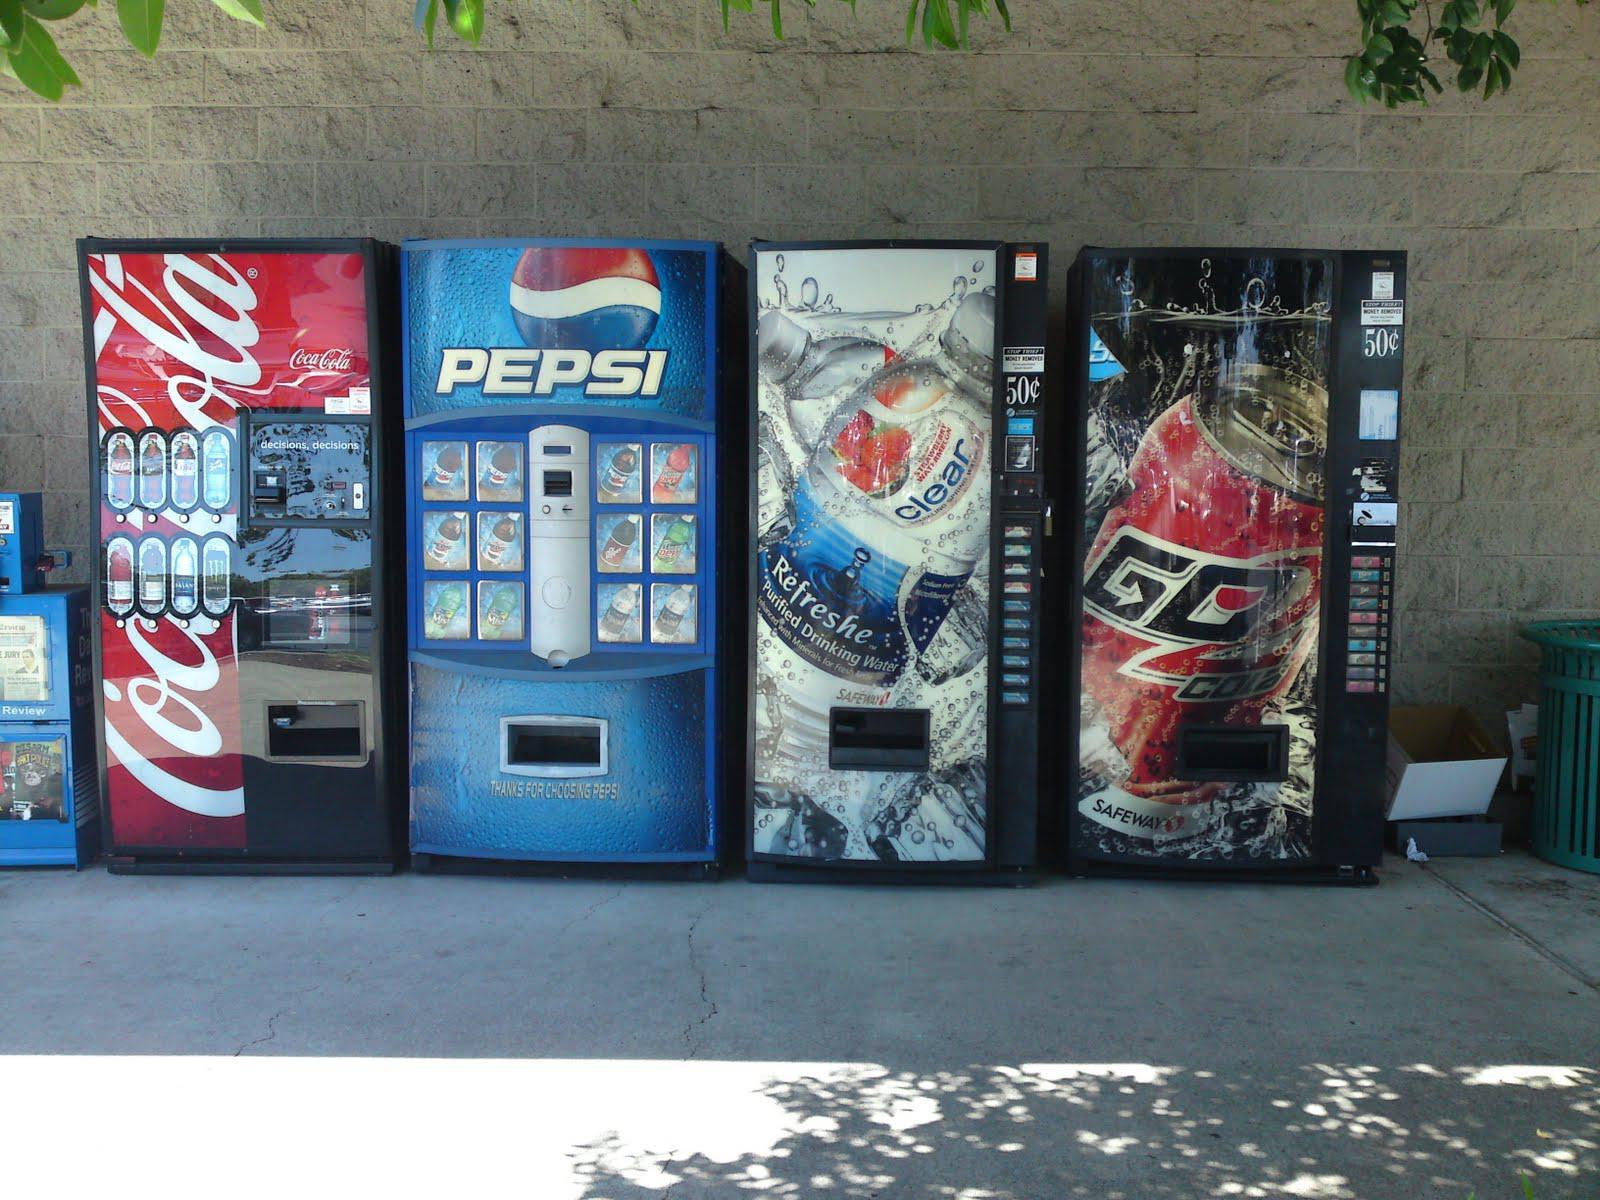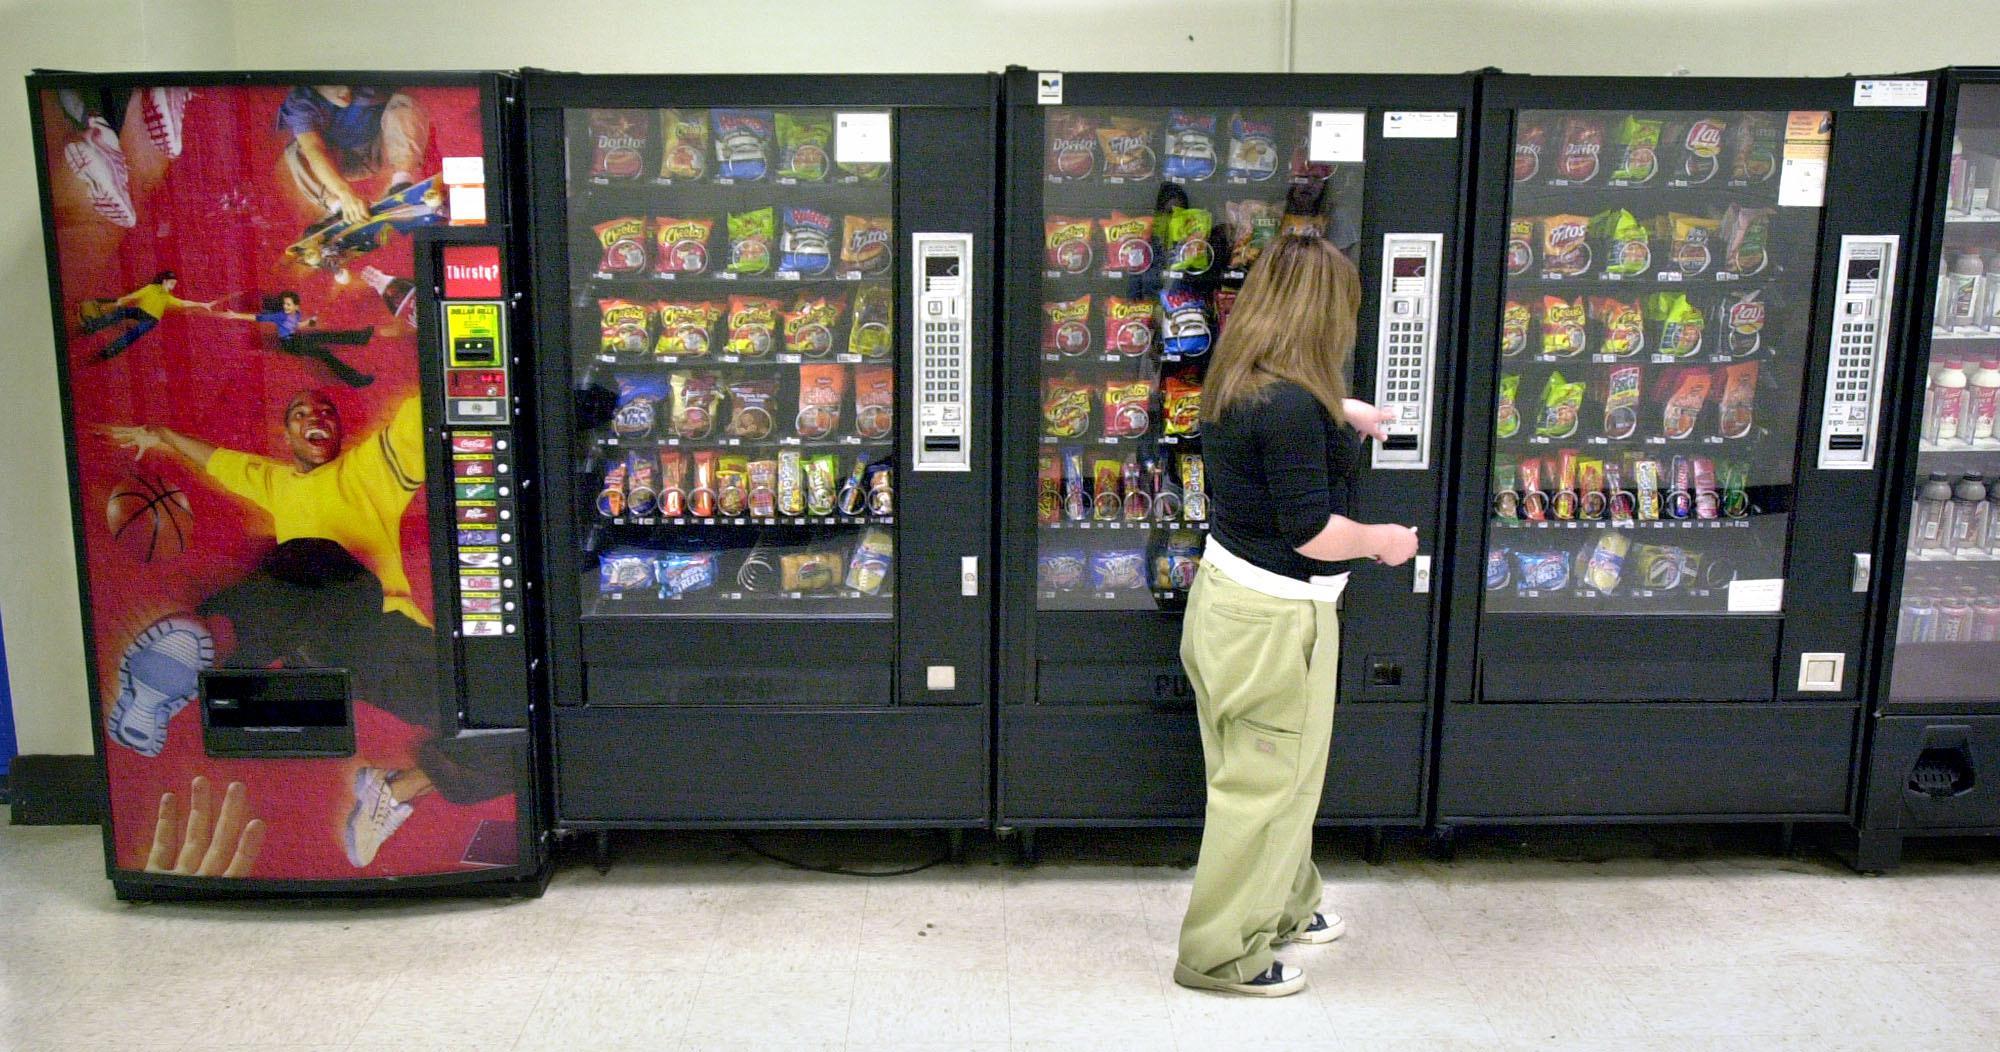The first image is the image on the left, the second image is the image on the right. Analyze the images presented: Is the assertion "The left image contains no more than two vending machines." valid? Answer yes or no. No. 